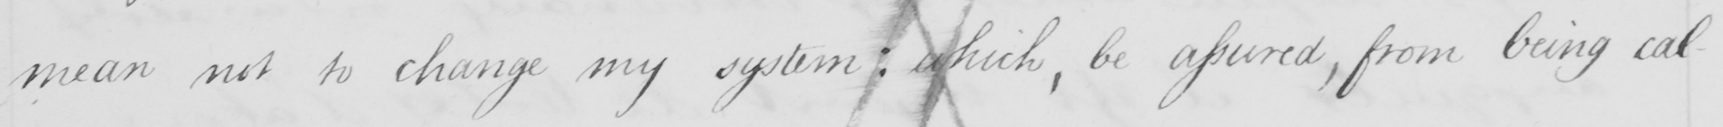Can you read and transcribe this handwriting? mean not to change my system; which, be assured, from being cal- 